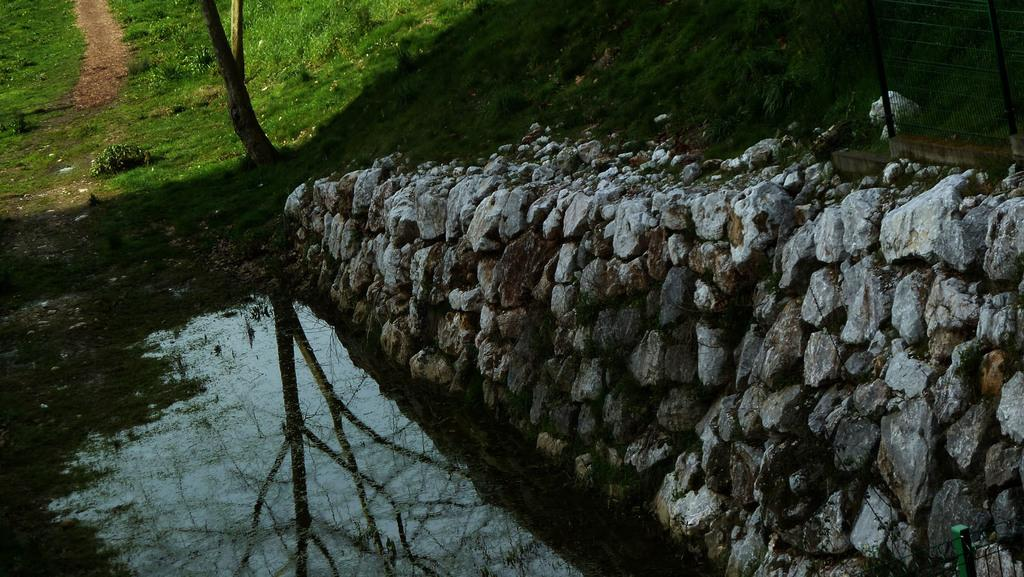What type of natural elements can be seen in the image? There are rocks and grass visible in the image. What is the water reflecting in the image? The water reflects trees in the image. What part of the natural environment is visible in the image? The sky is visible in the image. What is the title of the girl's book in the image? There is no girl or book present in the image. What type of wilderness can be seen in the image? The image does not depict a wilderness setting; it features rocks, grass, and a reflection of trees in the water. 